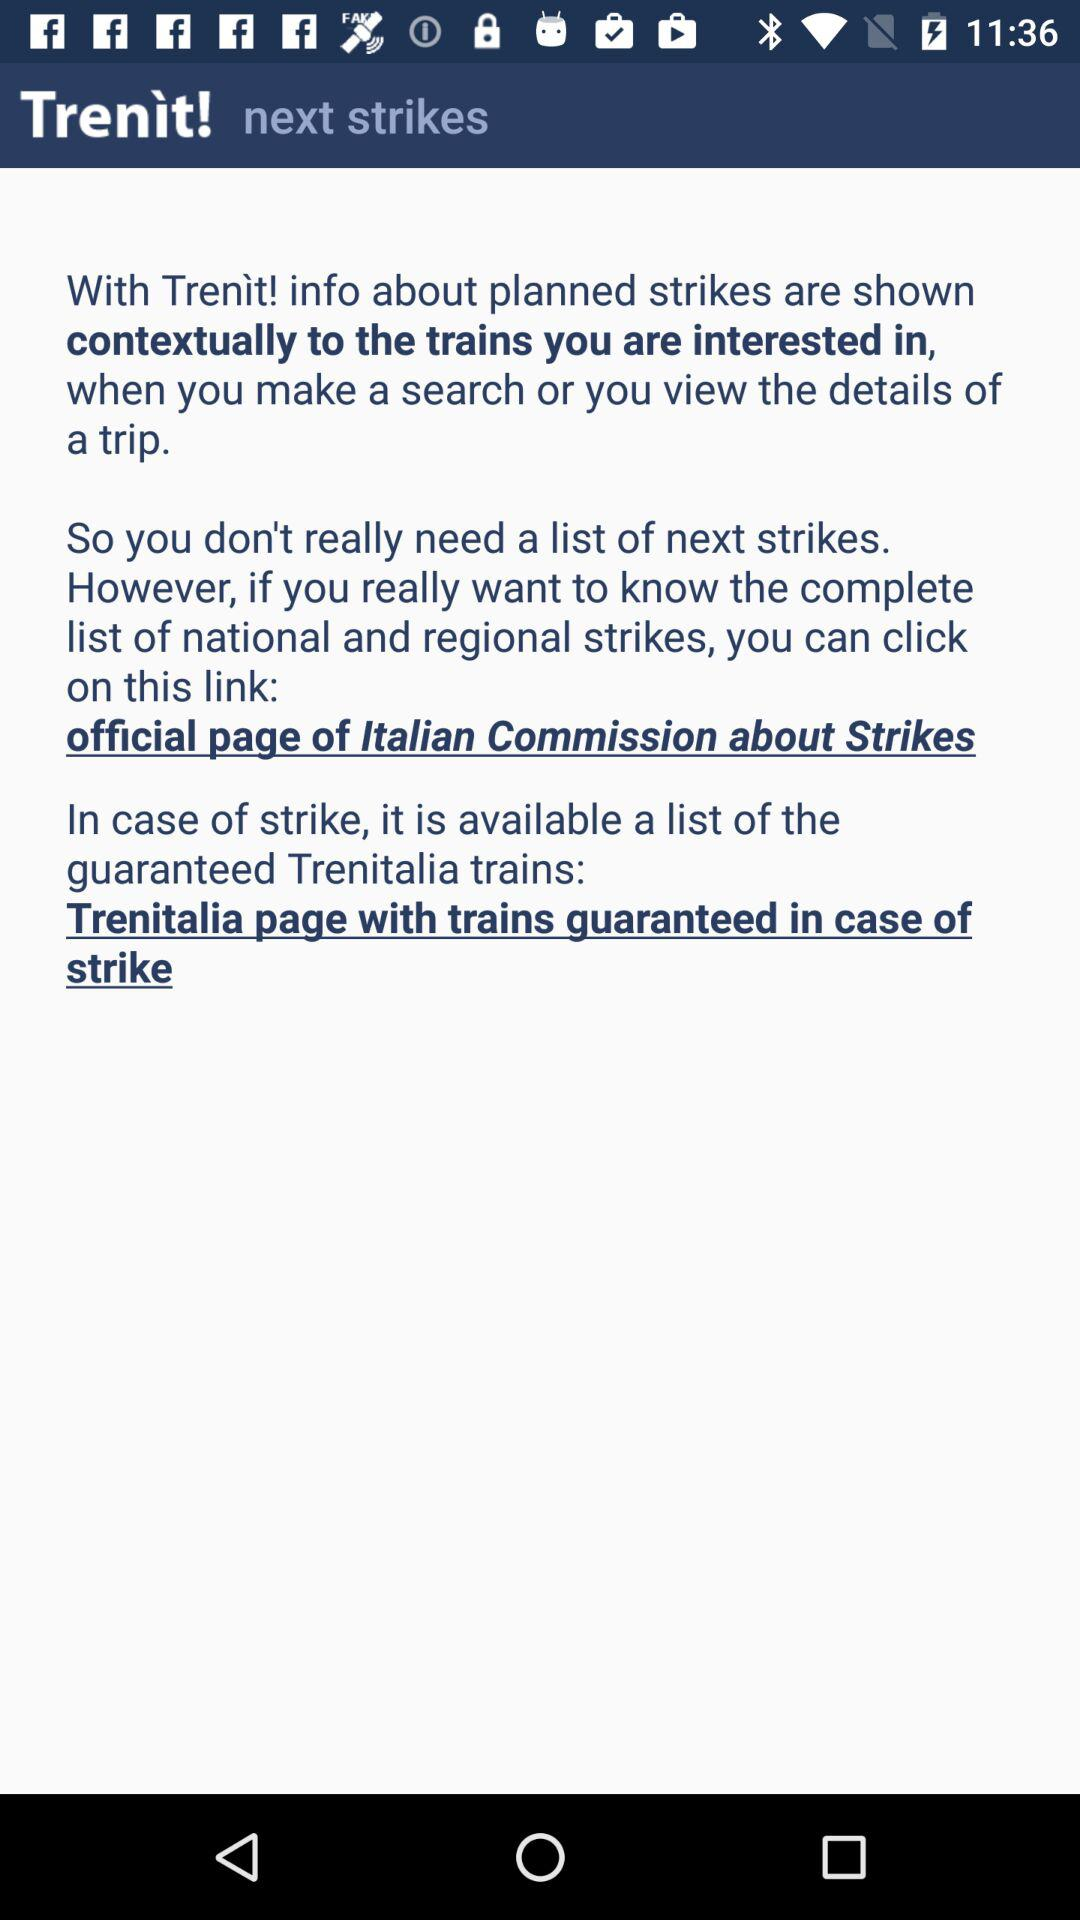How many links are there in the text?
Answer the question using a single word or phrase. 2 